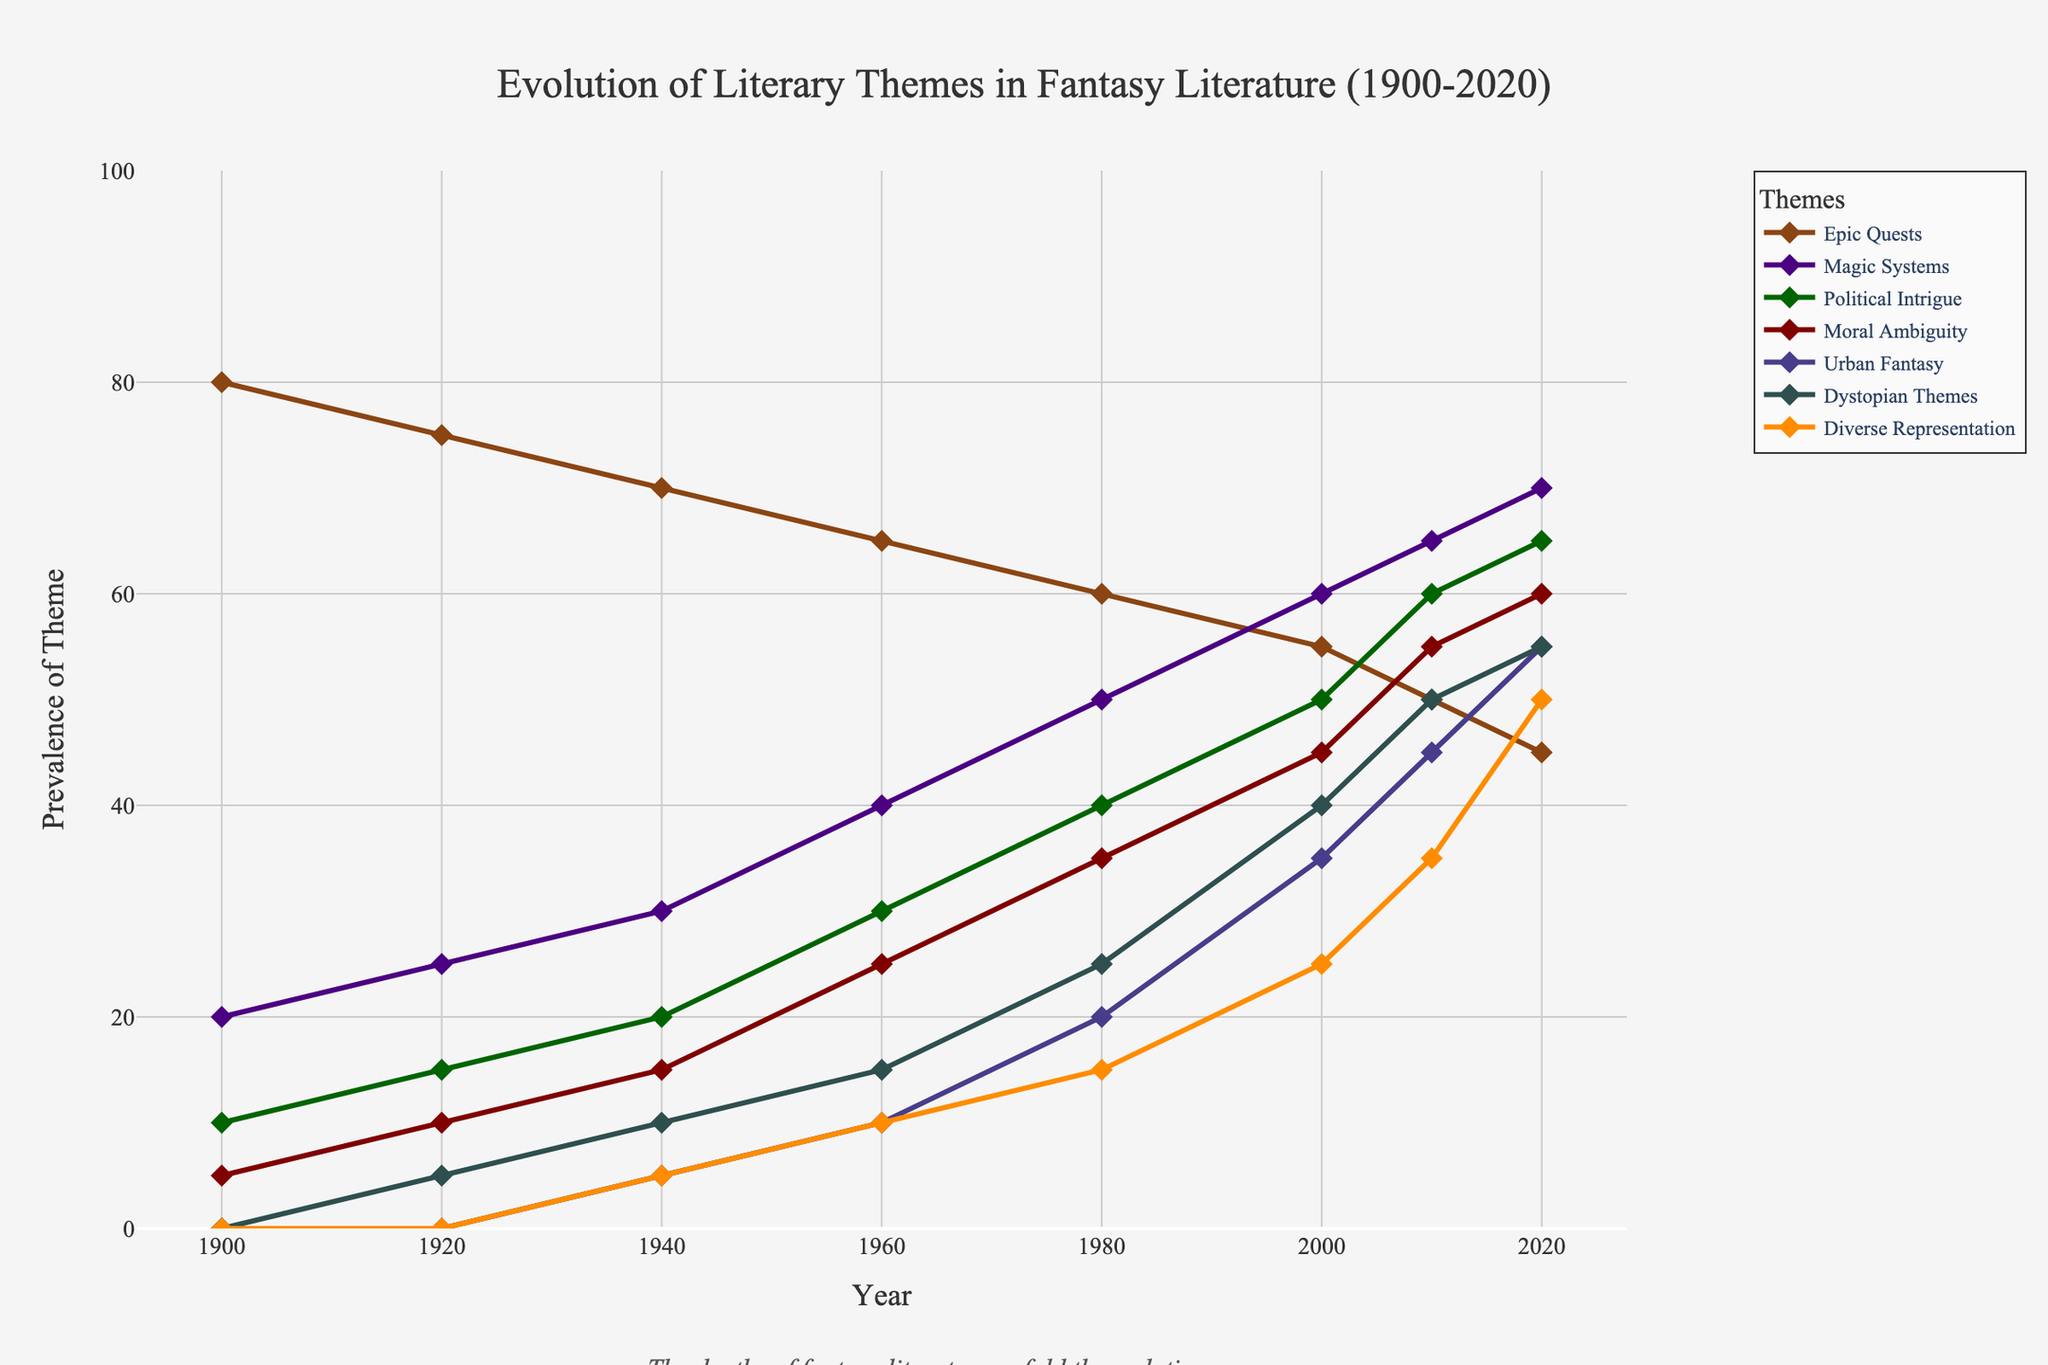Which theme had the highest prevalence in 2020? The figure shows several themes with their prevalence over the years. In 2020, "Magic Systems" had the highest prevalence with a value around 70.
Answer: Magic Systems How did the prevalence of "Urban Fantasy" change from 1940 to 2020? To find the change, we note the prevalence of "Urban Fantasy" in 1940 and 2020 and find the difference. In 1940, it was 5, and in 2020, it was 55. Thus, the change is 55 - 5 = 50.
Answer: Increased by 50 Which theme had the most significant increase between 1900 and 2020? By calculating the increase for each theme between 1900 and 2020, we find that "Magic Systems" had an increase from 20 to 70, which is the largest increase of 50.
Answer: Magic Systems In what year did "Diverse Representation" begin to appear? Observing the data points, "Diverse Representation" started to appear in 1940 with a prevalence of 5.
Answer: 1940 Which two themes have intersecting points where their prevalence values are equal? Upon visual inspection of the lines in the figure, "Magic Systems" and "Political Intrigue" intersect around the 2010 mark, indicating equal prevalence values.
Answer: Magic Systems and Political Intrigue What was the average prevalence of "Moral Ambiguity" over the recorded years? To calculate the average, add the prevalence values for "Moral Ambiguity" (5, 10, 15, 25, 35, 45, 55, 60) and divide by the number of data points (8). Sum: 250, Average: 250/8 = 31.25.
Answer: 31.25 Compare the prevalence trends of "Epic Quests" and "Dystopian Themes". Which theme shows a decreasing trend and which shows an increasing trend? Observing the figure, "Epic Quests" shows a decreasing trend from 1900 to 2020, while "Dystopian Themes" displays an increasing trend over the same period.
Answer: Epic Quests decreases, Dystopian Themes increases By how much did "Political Intrigue" increase from 1920 to 2020? To find the increase, we note the prevalence in 1920 (15) and in 2020 (65). The increase is 65 - 15 = 50.
Answer: 50 Which theme had a prevalence of 50 around 2010? By looking at the data, "Political Intrigue" was at 50 prevalence in 2010.
Answer: Political Intrigue What is the trend of "Diverse Representation" from 1940 to 2020? Following the data points for "Diverse Representation" from 1940 (5) to 2020 (50), we see a consistent increase, indicating an upward trend.
Answer: Increasing trend 